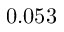Convert formula to latex. <formula><loc_0><loc_0><loc_500><loc_500>0 . 0 5 3</formula> 